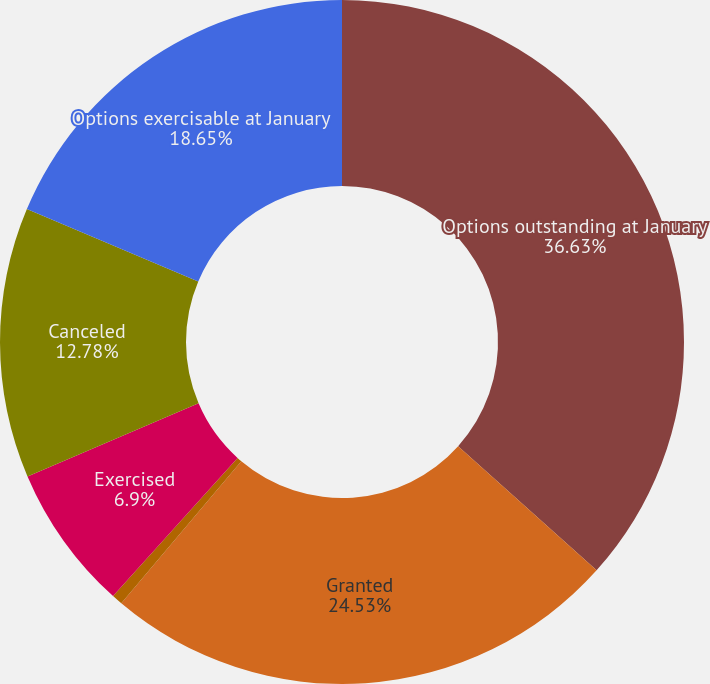Convert chart. <chart><loc_0><loc_0><loc_500><loc_500><pie_chart><fcel>Options outstanding at January<fcel>Granted<fcel>Options assumed in<fcel>Exercised<fcel>Canceled<fcel>Options exercisable at January<nl><fcel>36.64%<fcel>24.53%<fcel>0.51%<fcel>6.9%<fcel>12.78%<fcel>18.65%<nl></chart> 